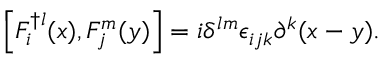<formula> <loc_0><loc_0><loc_500><loc_500>\left [ F _ { i } ^ { \dagger l } ( x ) , F _ { j } ^ { m } ( y ) \right ] = i \delta ^ { l m } \epsilon _ { i j k } \partial ^ { k } ( x - y ) .</formula> 